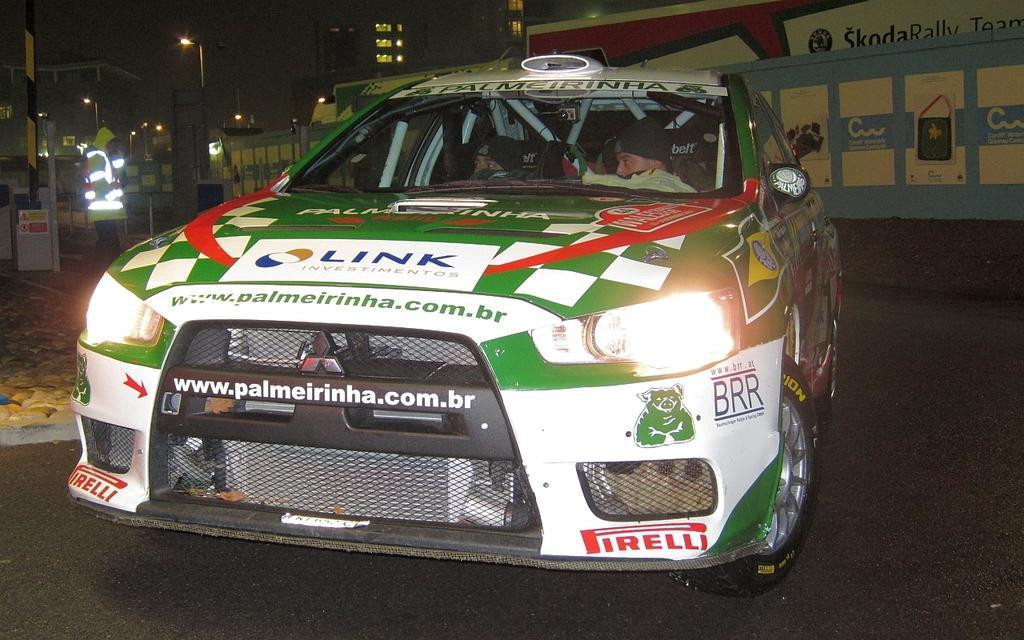What is the main subject of the image? There is a car in the center of the image. Where is the car located? The car is on the road. What can be seen in the background of the image? There are buildings in the background of the image. What other objects are present in the image? There are light poles in the image. Can you describe the wall in the image? There is a wall with posters in the image. What color is the nail used to hang the posters on the wall? There is no nail visible in the image, and the color of any nail used to hang the posters cannot be determined. 